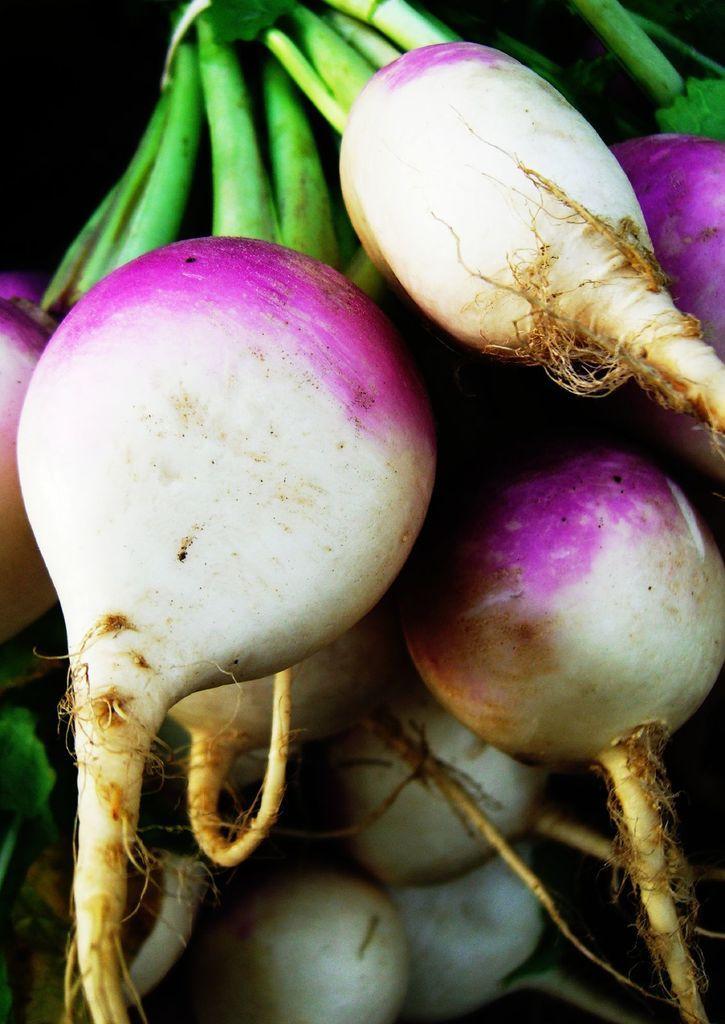Please provide a concise description of this image. In the foreground of this image, there are turnips and we can also see their stems. 